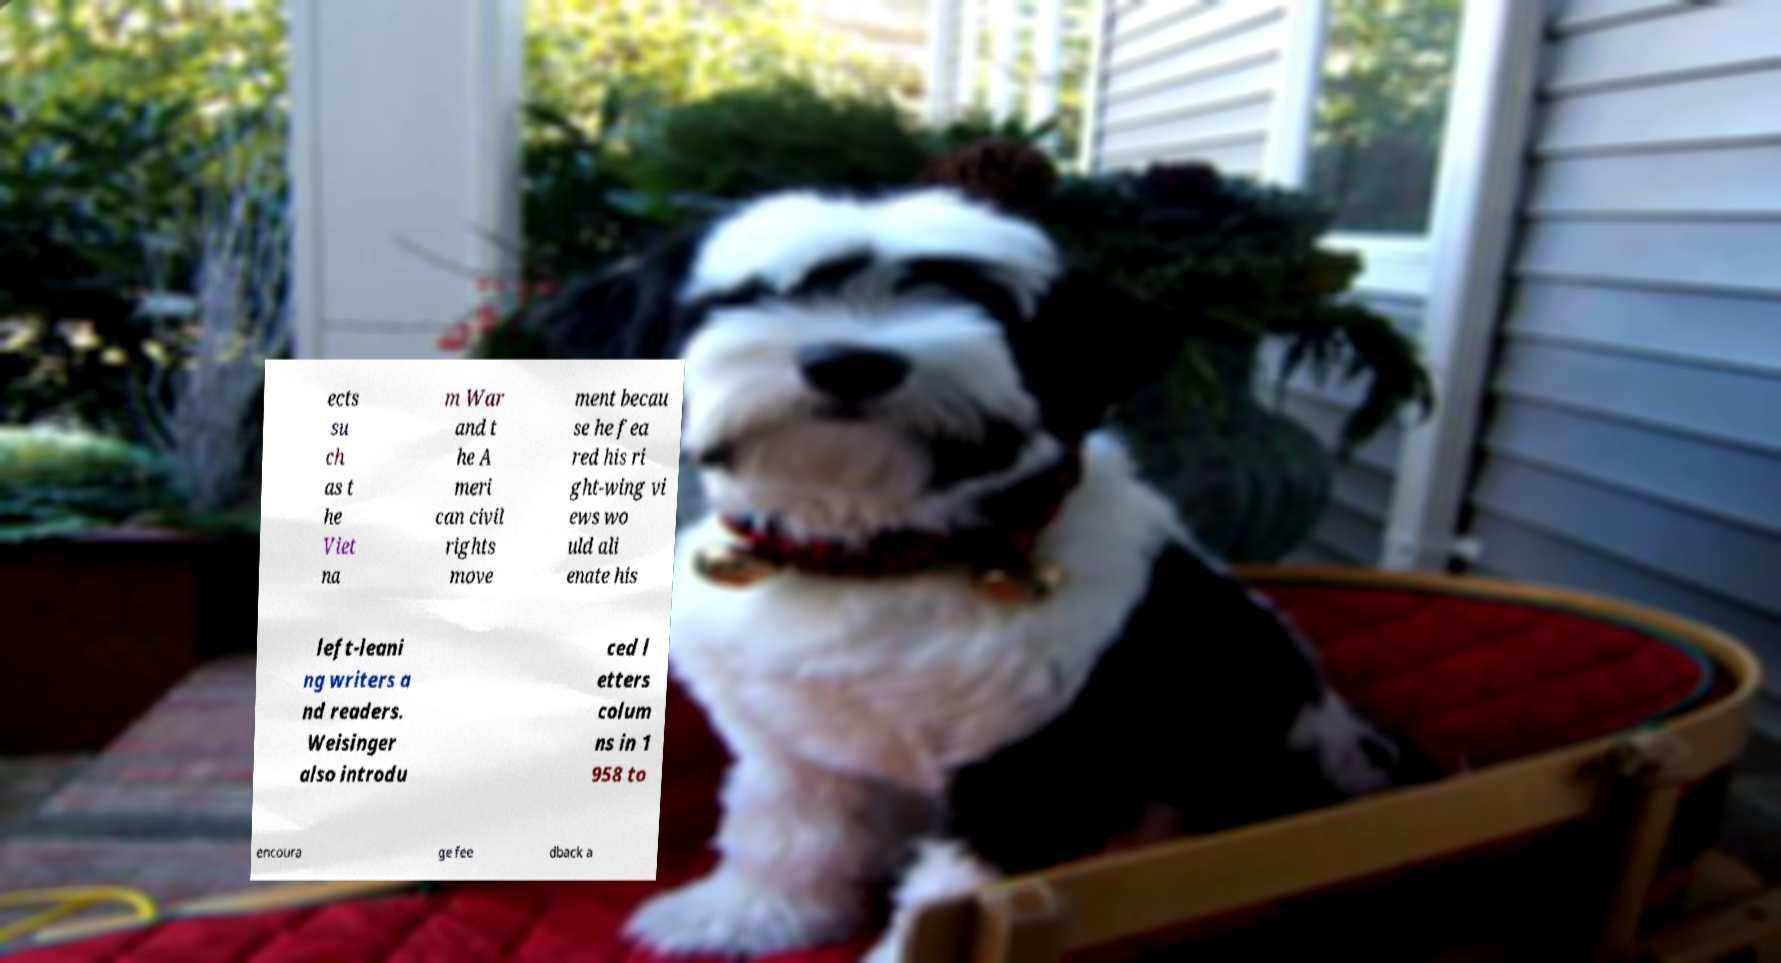Could you assist in decoding the text presented in this image and type it out clearly? ects su ch as t he Viet na m War and t he A meri can civil rights move ment becau se he fea red his ri ght-wing vi ews wo uld ali enate his left-leani ng writers a nd readers. Weisinger also introdu ced l etters colum ns in 1 958 to encoura ge fee dback a 